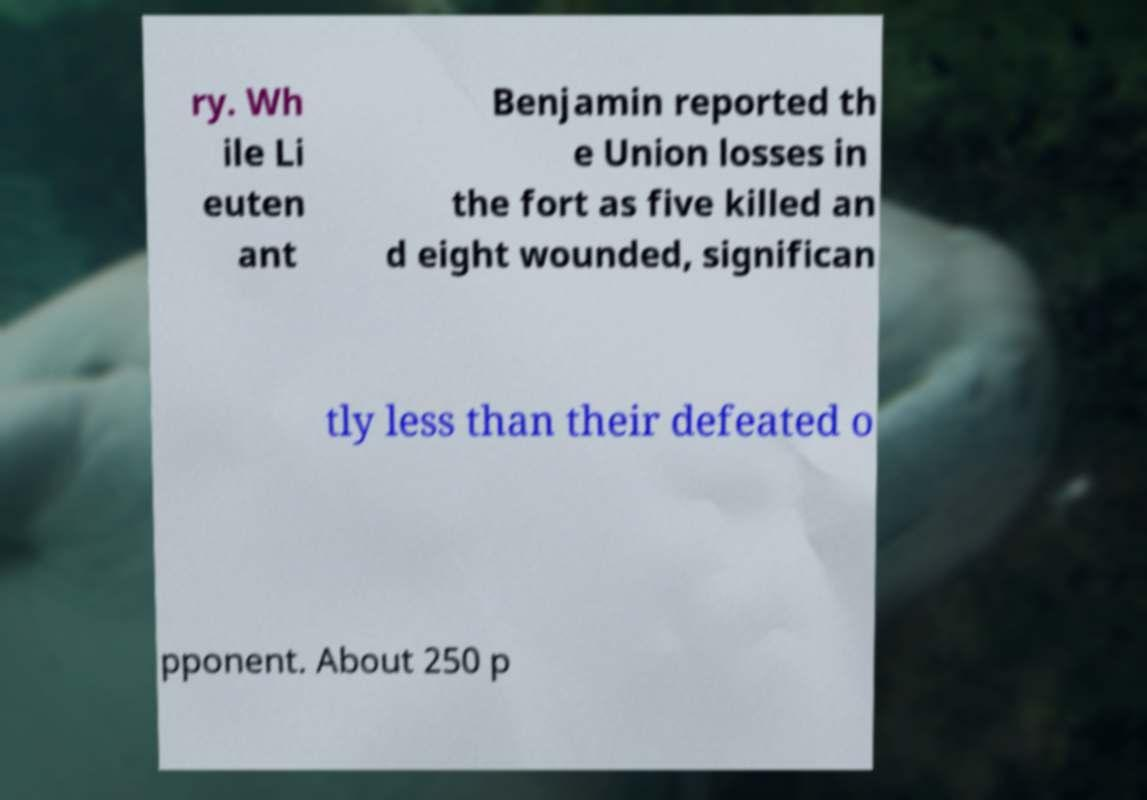There's text embedded in this image that I need extracted. Can you transcribe it verbatim? ry. Wh ile Li euten ant Benjamin reported th e Union losses in the fort as five killed an d eight wounded, significan tly less than their defeated o pponent. About 250 p 